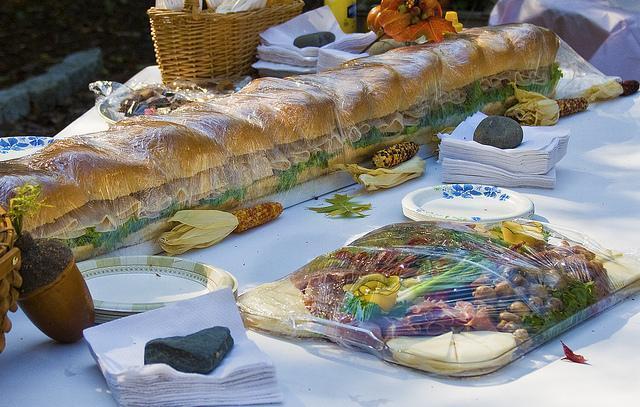Is the caption "The sandwich is on the dining table." a true representation of the image?
Answer yes or no. Yes. 